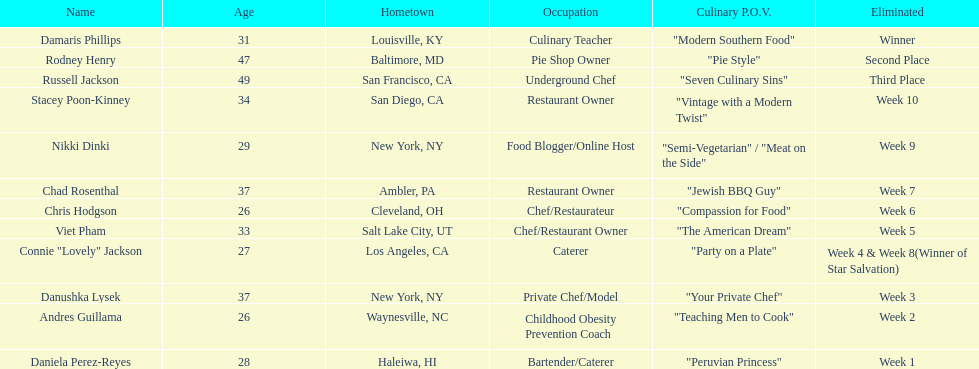Which contestant is the same age as chris hodgson? Andres Guillama. 